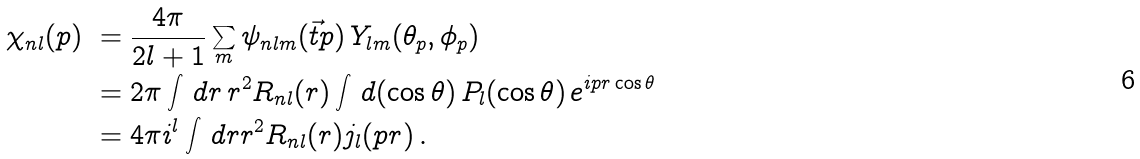Convert formula to latex. <formula><loc_0><loc_0><loc_500><loc_500>\chi _ { n l } ( p ) \ & = \frac { 4 \pi } { 2 l + 1 } \sum _ { m } \psi _ { n l m } ( \vec { t } { p } ) \, Y _ { l m } ( \theta _ { p } , \phi _ { p } ) \\ & = 2 \pi \int \, d r \, r ^ { 2 } R _ { n l } ( r ) \int \, d ( \cos \theta ) \, P _ { l } ( \cos \theta ) \, e ^ { i p r \cos \theta } \\ & = 4 \pi i ^ { l } \int \, d r r ^ { 2 } R _ { n l } ( r ) j _ { l } ( p r ) \, .</formula> 